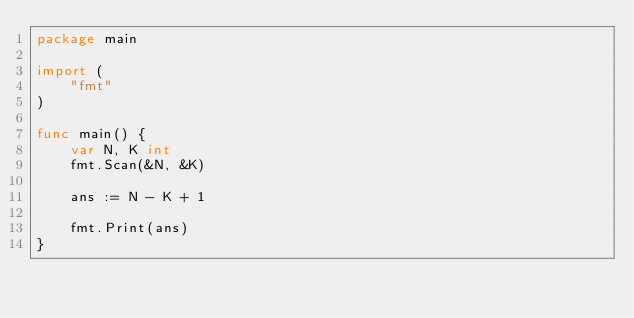<code> <loc_0><loc_0><loc_500><loc_500><_Go_>package main

import (
	"fmt"
)

func main() {
	var N, K int
	fmt.Scan(&N, &K)

	ans := N - K + 1

	fmt.Print(ans)
}</code> 